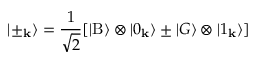<formula> <loc_0><loc_0><loc_500><loc_500>| \pm _ { k } \rangle = \frac { 1 } { \sqrt { 2 } } [ | B \rangle \otimes | 0 _ { k } \rangle \pm | G \rangle \otimes | 1 _ { k } \rangle ]</formula> 